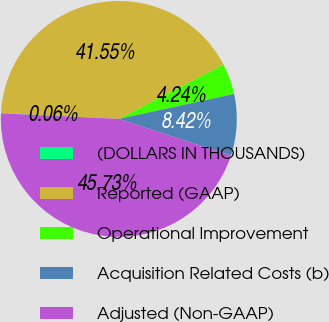<chart> <loc_0><loc_0><loc_500><loc_500><pie_chart><fcel>(DOLLARS IN THOUSANDS)<fcel>Reported (GAAP)<fcel>Operational Improvement<fcel>Acquisition Related Costs (b)<fcel>Adjusted (Non-GAAP)<nl><fcel>0.06%<fcel>41.55%<fcel>4.24%<fcel>8.42%<fcel>45.73%<nl></chart> 